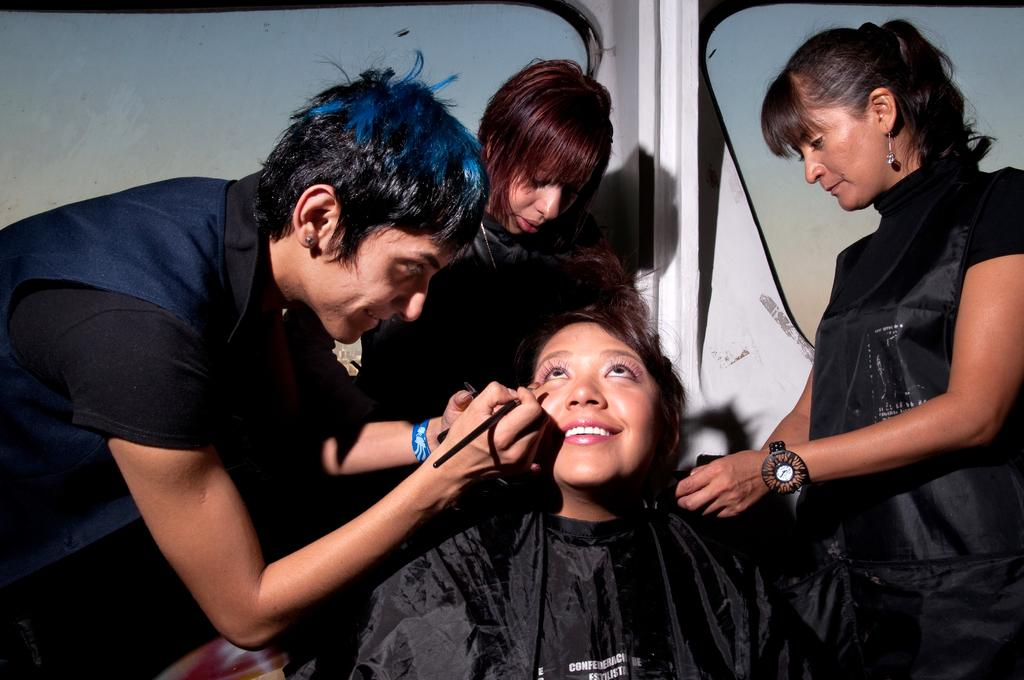What are the people in the image doing? There are people standing and one person is sitting in the image. Can you describe the person who is holding an object? One person is holding a brush in the image. What can be seen in the background of the image? There are glass windows in the background of the image. How many chickens are visible in the image? There are no chickens present in the image. What type of war is being depicted in the image? There is no depiction of war in the image. 